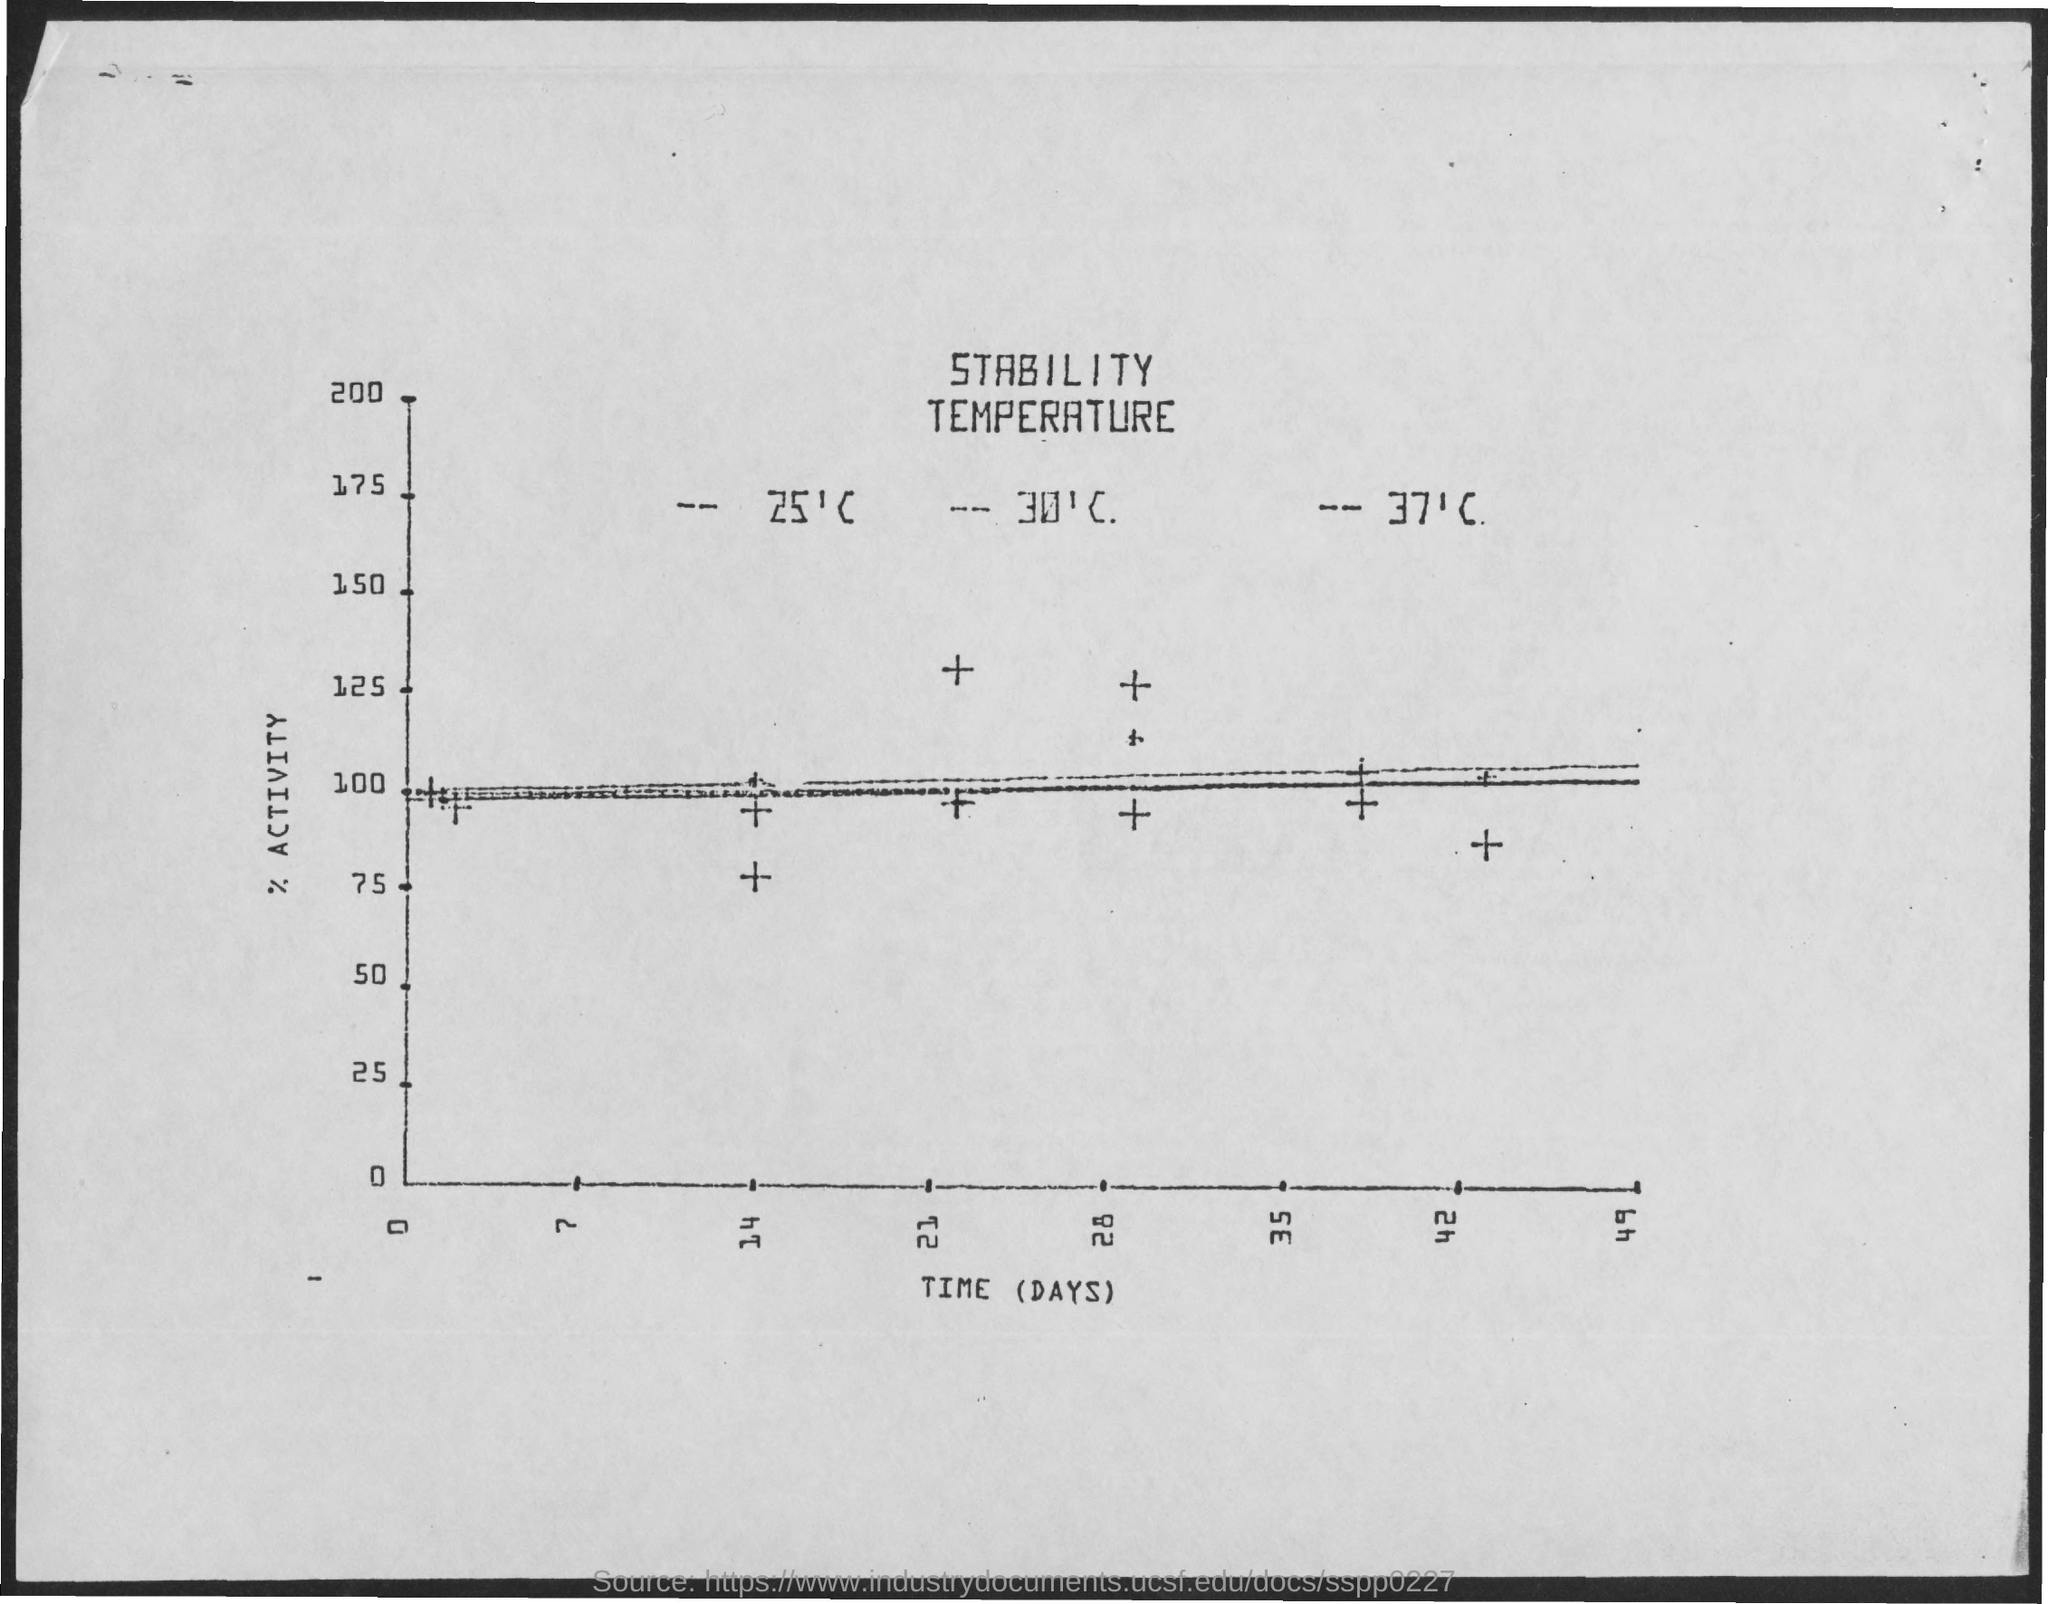Indicate a few pertinent items in this graphic. The y-axis represents the level of activity, %. The x-axis in the plot displays time in days. 